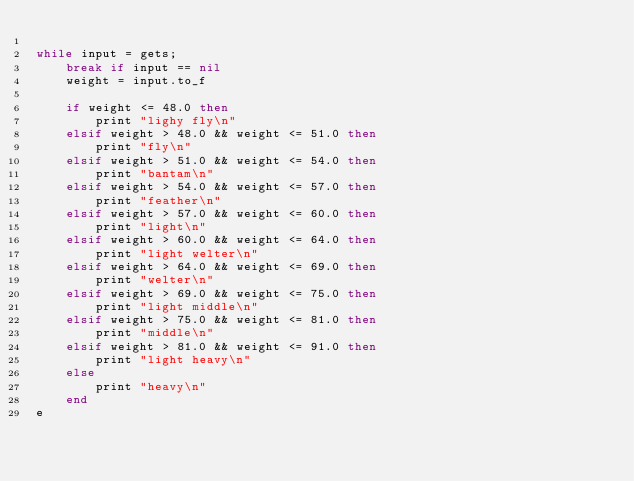<code> <loc_0><loc_0><loc_500><loc_500><_Ruby_>
while input = gets;
	break if input == nil
	weight = input.to_f

	if weight <= 48.0 then
		print "lighy fly\n"
	elsif weight > 48.0 && weight <= 51.0 then
		print "fly\n"
	elsif weight > 51.0 && weight <= 54.0 then
		print "bantam\n"
	elsif weight > 54.0 && weight <= 57.0 then 
		print "feather\n"
	elsif weight > 57.0 && weight <= 60.0 then
		print "light\n"
	elsif weight > 60.0 && weight <= 64.0 then
		print "light welter\n"
	elsif weight > 64.0 && weight <= 69.0 then
		print "welter\n"
	elsif weight > 69.0 && weight <= 75.0 then
		print "light middle\n"
	elsif weight > 75.0 && weight <= 81.0 then
		print "middle\n"
	elsif weight > 81.0 && weight <= 91.0 then
		print "light heavy\n"
	else
		print "heavy\n"
	end
e</code> 